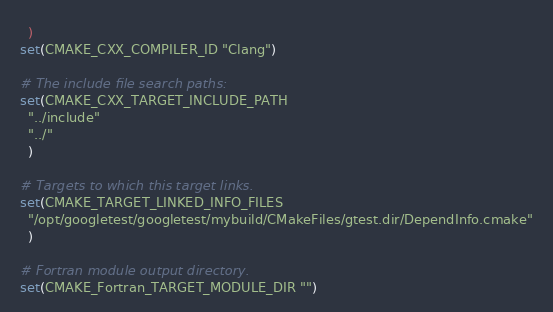Convert code to text. <code><loc_0><loc_0><loc_500><loc_500><_CMake_>  )
set(CMAKE_CXX_COMPILER_ID "Clang")

# The include file search paths:
set(CMAKE_CXX_TARGET_INCLUDE_PATH
  "../include"
  "../"
  )

# Targets to which this target links.
set(CMAKE_TARGET_LINKED_INFO_FILES
  "/opt/googletest/googletest/mybuild/CMakeFiles/gtest.dir/DependInfo.cmake"
  )

# Fortran module output directory.
set(CMAKE_Fortran_TARGET_MODULE_DIR "")
</code> 